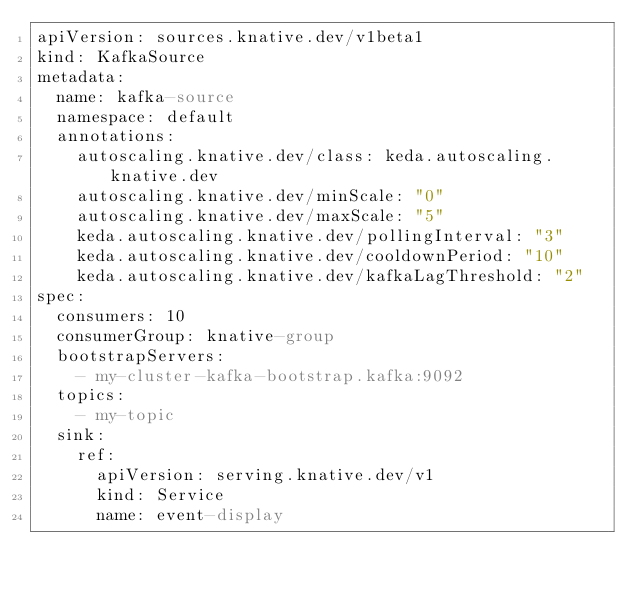<code> <loc_0><loc_0><loc_500><loc_500><_YAML_>apiVersion: sources.knative.dev/v1beta1
kind: KafkaSource
metadata:
  name: kafka-source
  namespace: default
  annotations:
    autoscaling.knative.dev/class: keda.autoscaling.knative.dev
    autoscaling.knative.dev/minScale: "0" 
    autoscaling.knative.dev/maxScale: "5" 
    keda.autoscaling.knative.dev/pollingInterval: "3" 
    keda.autoscaling.knative.dev/cooldownPeriod: "10" 
    keda.autoscaling.knative.dev/kafkaLagThreshold: "2"
spec:
  consumers: 10
  consumerGroup: knative-group
  bootstrapServers:
    - my-cluster-kafka-bootstrap.kafka:9092
  topics:
    - my-topic
  sink:
    ref:
      apiVersion: serving.knative.dev/v1
      kind: Service
      name: event-display
</code> 